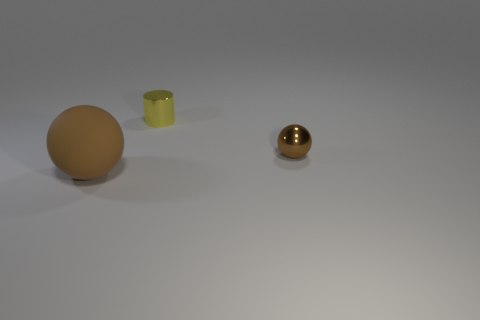Are there any other things that have the same material as the big sphere?
Offer a terse response. No. What is the brown ball in front of the tiny brown metal ball made of?
Provide a short and direct response. Rubber. Are there an equal number of small spheres that are in front of the small yellow metallic thing and large things?
Offer a very short reply. Yes. Do the big brown object and the tiny brown metal thing have the same shape?
Your response must be concise. Yes. Is there any other thing of the same color as the tiny shiny cylinder?
Your response must be concise. No. What shape is the thing that is to the left of the small metallic ball and in front of the small yellow metallic thing?
Offer a terse response. Sphere. Are there an equal number of brown spheres that are on the right side of the tiny brown ball and cylinders that are in front of the small yellow cylinder?
Provide a short and direct response. Yes. What number of cylinders are either brown metal objects or small yellow metallic things?
Your answer should be very brief. 1. What number of green cubes have the same material as the small brown thing?
Provide a succinct answer. 0. There is a tiny thing that is the same color as the big ball; what shape is it?
Offer a terse response. Sphere. 